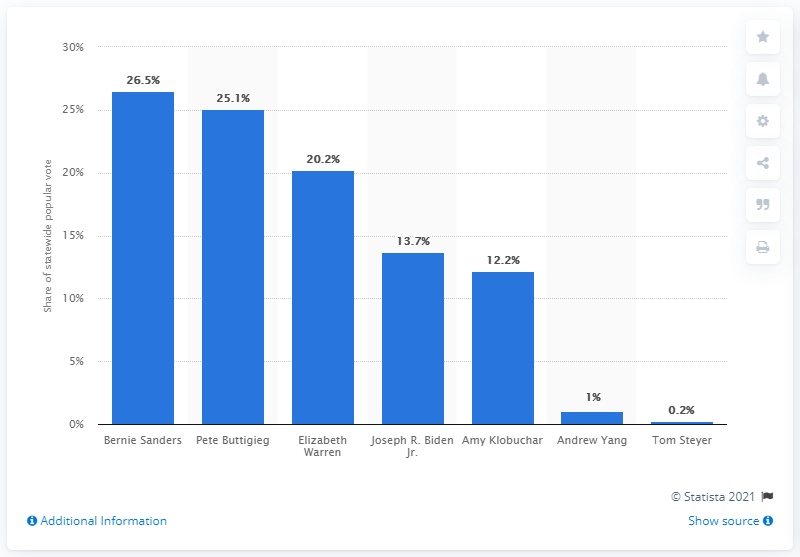Specify some key components in this picture. Pete Buttigieg received 25.1% of the statewide popular vote in the state. Bernie Sanders received 26.5% of the statewide popular vote in the 2020 Iowa Caucus. Pete Buttigieg holds a slim advantage over Bernie Sanders in the current polls. 